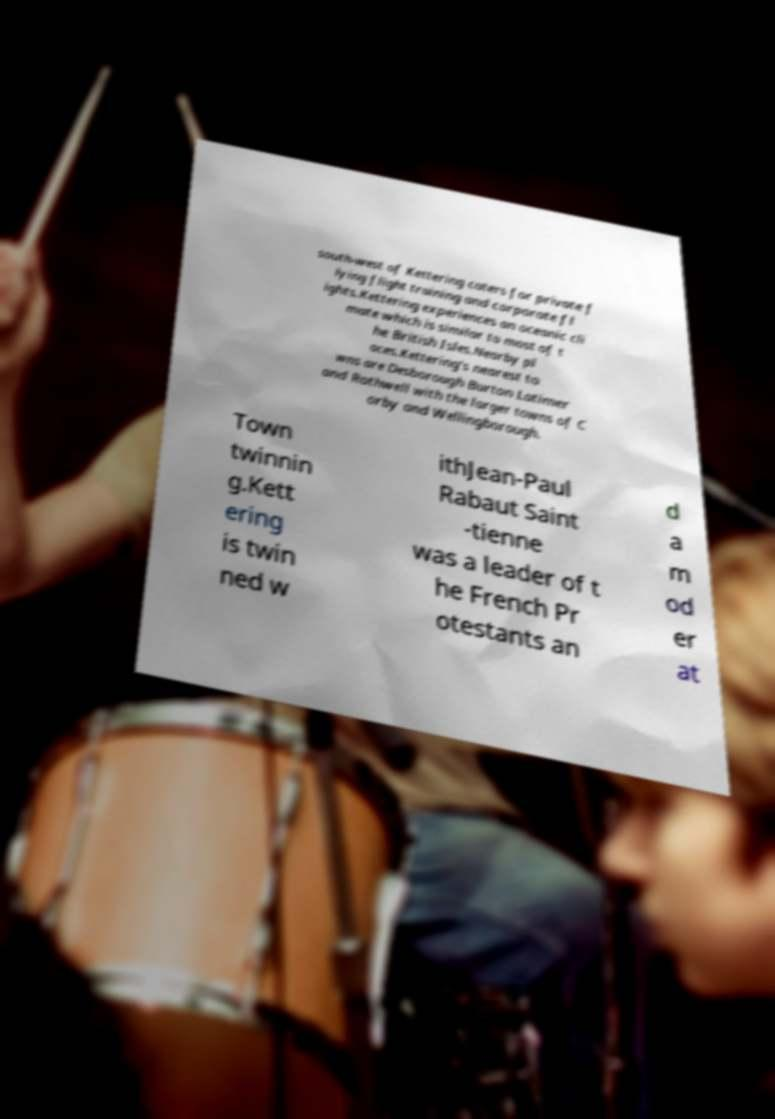For documentation purposes, I need the text within this image transcribed. Could you provide that? south-west of Kettering caters for private f lying flight training and corporate fl ights.Kettering experiences an oceanic cli mate which is similar to most of t he British Isles.Nearby pl aces.Kettering's nearest to wns are Desborough Burton Latimer and Rothwell with the larger towns of C orby and Wellingborough. Town twinnin g.Kett ering is twin ned w ithJean-Paul Rabaut Saint -tienne was a leader of t he French Pr otestants an d a m od er at 